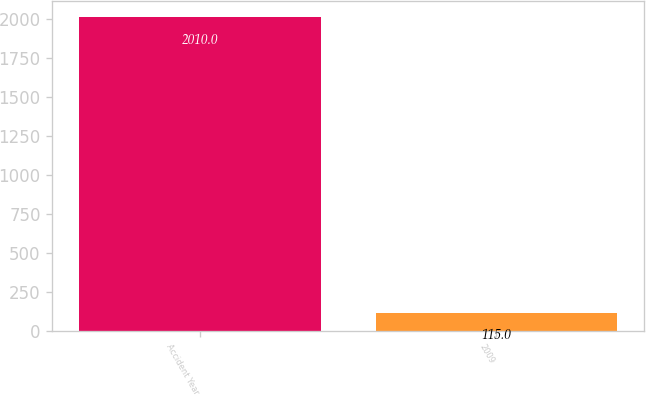<chart> <loc_0><loc_0><loc_500><loc_500><bar_chart><fcel>Accident Year<fcel>2009<nl><fcel>2010<fcel>115<nl></chart> 